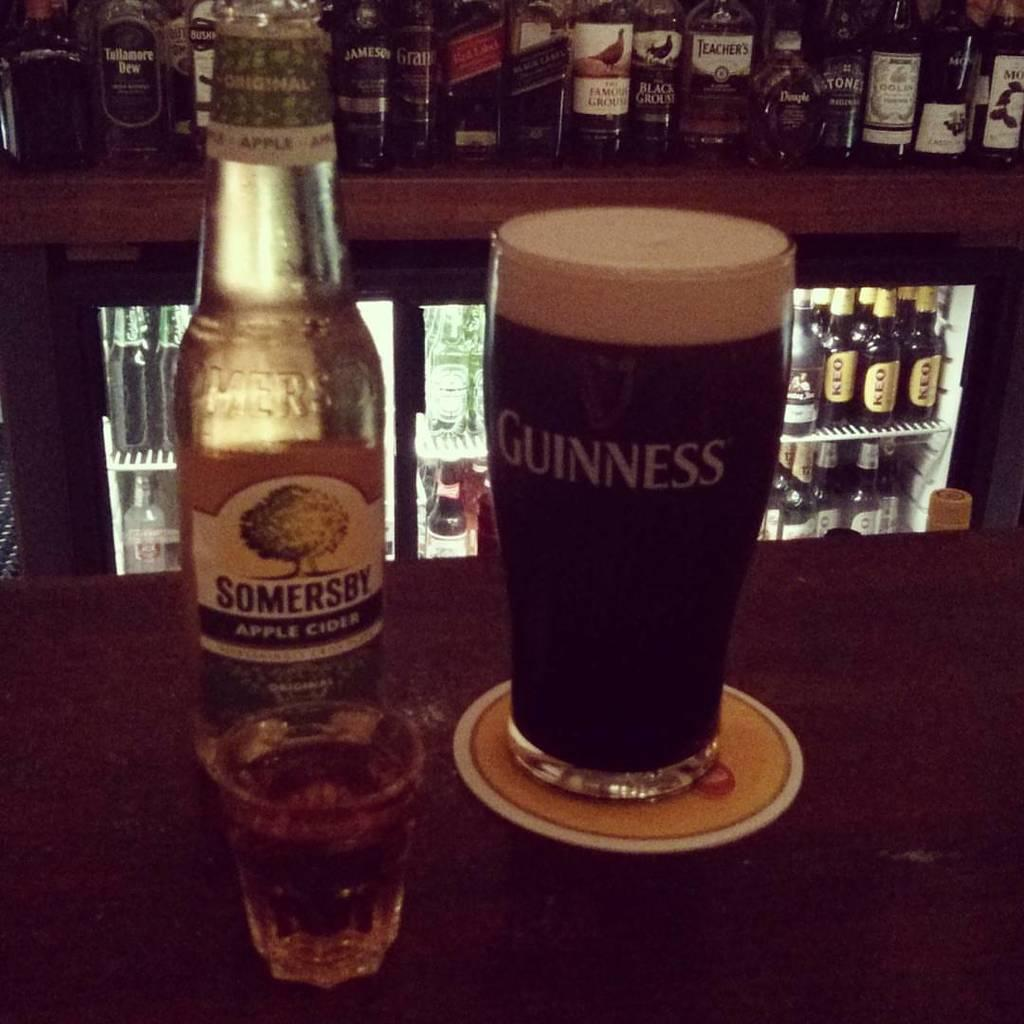<image>
Summarize the visual content of the image. Few bottles of Somersby apple cider and guinness and a glass 